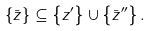Convert formula to latex. <formula><loc_0><loc_0><loc_500><loc_500>\{ \bar { z } \} \subseteq \left \{ z ^ { \prime } \right \} \cup \left \{ \bar { z } ^ { \prime \prime } \right \} .</formula> 